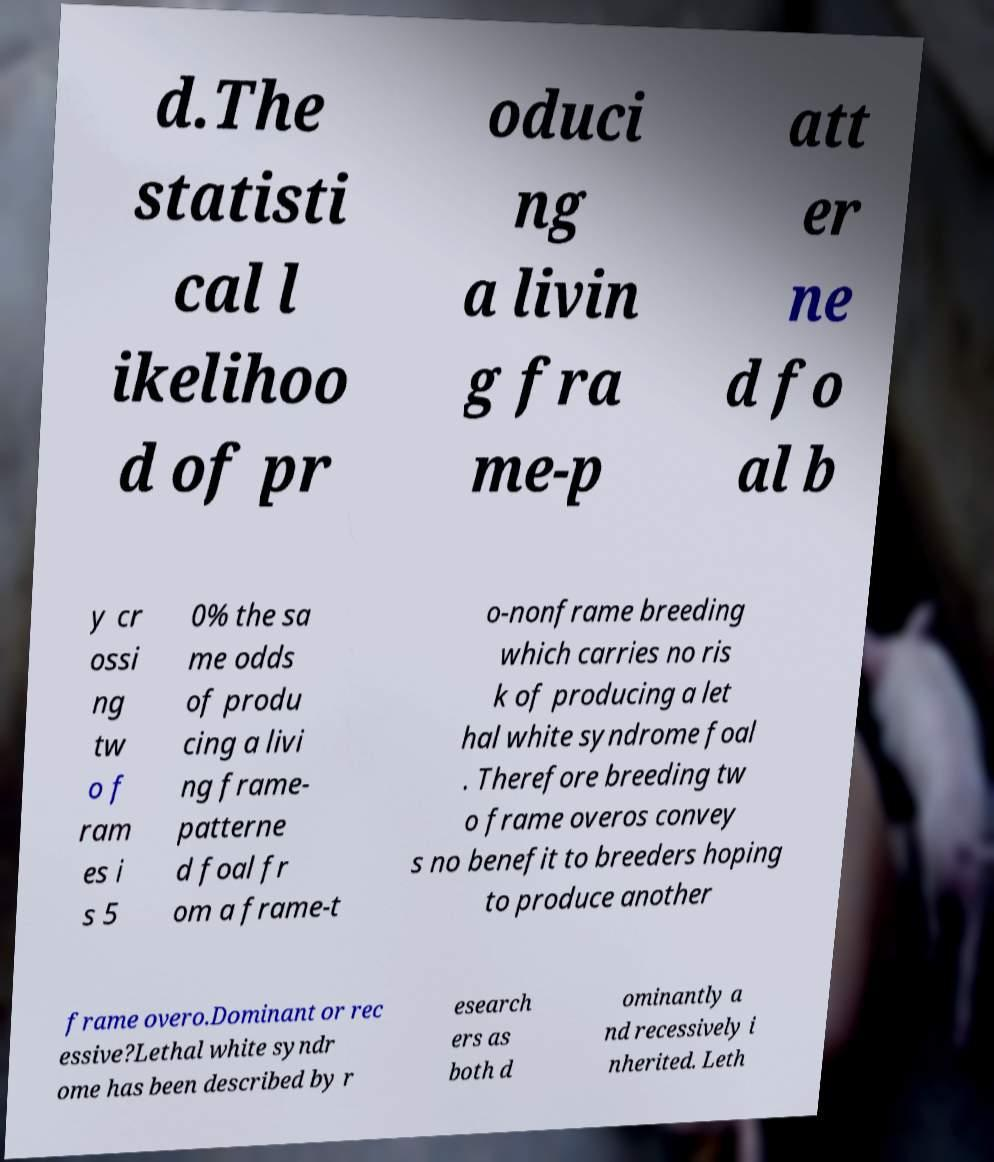Could you extract and type out the text from this image? d.The statisti cal l ikelihoo d of pr oduci ng a livin g fra me-p att er ne d fo al b y cr ossi ng tw o f ram es i s 5 0% the sa me odds of produ cing a livi ng frame- patterne d foal fr om a frame-t o-nonframe breeding which carries no ris k of producing a let hal white syndrome foal . Therefore breeding tw o frame overos convey s no benefit to breeders hoping to produce another frame overo.Dominant or rec essive?Lethal white syndr ome has been described by r esearch ers as both d ominantly a nd recessively i nherited. Leth 